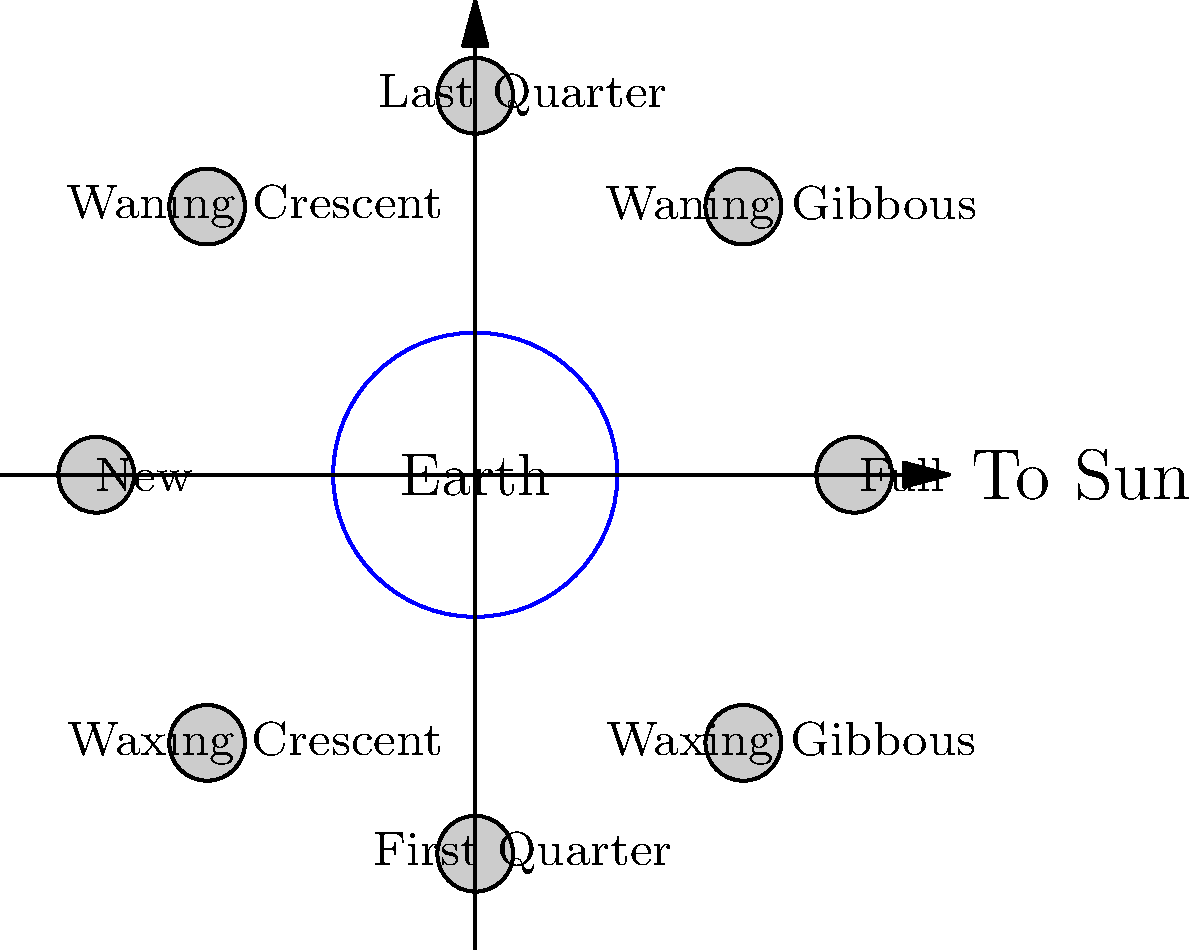In our journey through life and love, we often find parallels between celestial phenomena and our relationships. Consider the phases of the moon as shown in the diagram. Which phase occurs when the moon is positioned directly between the Earth and the Sun, symbolizing a moment of perfect alignment in a relationship? To answer this question, let's go through the moon's phases step-by-step:

1. The diagram shows the Earth at the center, with the moon's orbit around it.
2. The arrow pointing to the right indicates the direction of the Sun.
3. The moon's phases are labeled around its orbit.
4. When the moon is directly between the Earth and the Sun, it is in the position labeled "New" on the left side of the diagram.
5. During a New Moon phase:
   - The side of the moon facing the Earth is completely dark.
   - This occurs because the illuminated side of the moon is facing away from Earth, towards the Sun.
   - From Earth's perspective, the moon is not visible in the night sky.
6. In terms of the relationship analogy:
   - The New Moon could symbolize a moment of perfect alignment or understanding between partners.
   - Just as the moon is directly between Earth and Sun, partners might find themselves in complete harmony, facing challenges together.

The New Moon phase occurs when the moon is positioned exactly between the Earth and the Sun, making it the correct answer to this question.
Answer: New Moon 